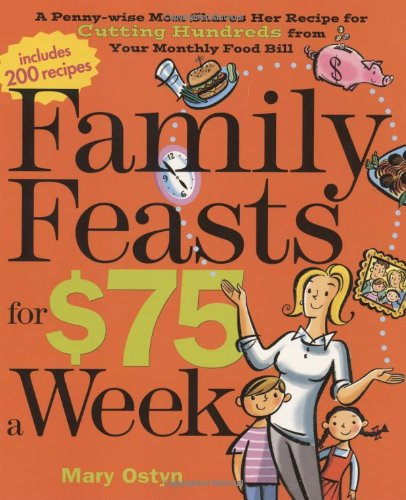Is this a recipe book? Yes, it is a recipe book aimed at helping families prepare meals that are both delicious and economical. 